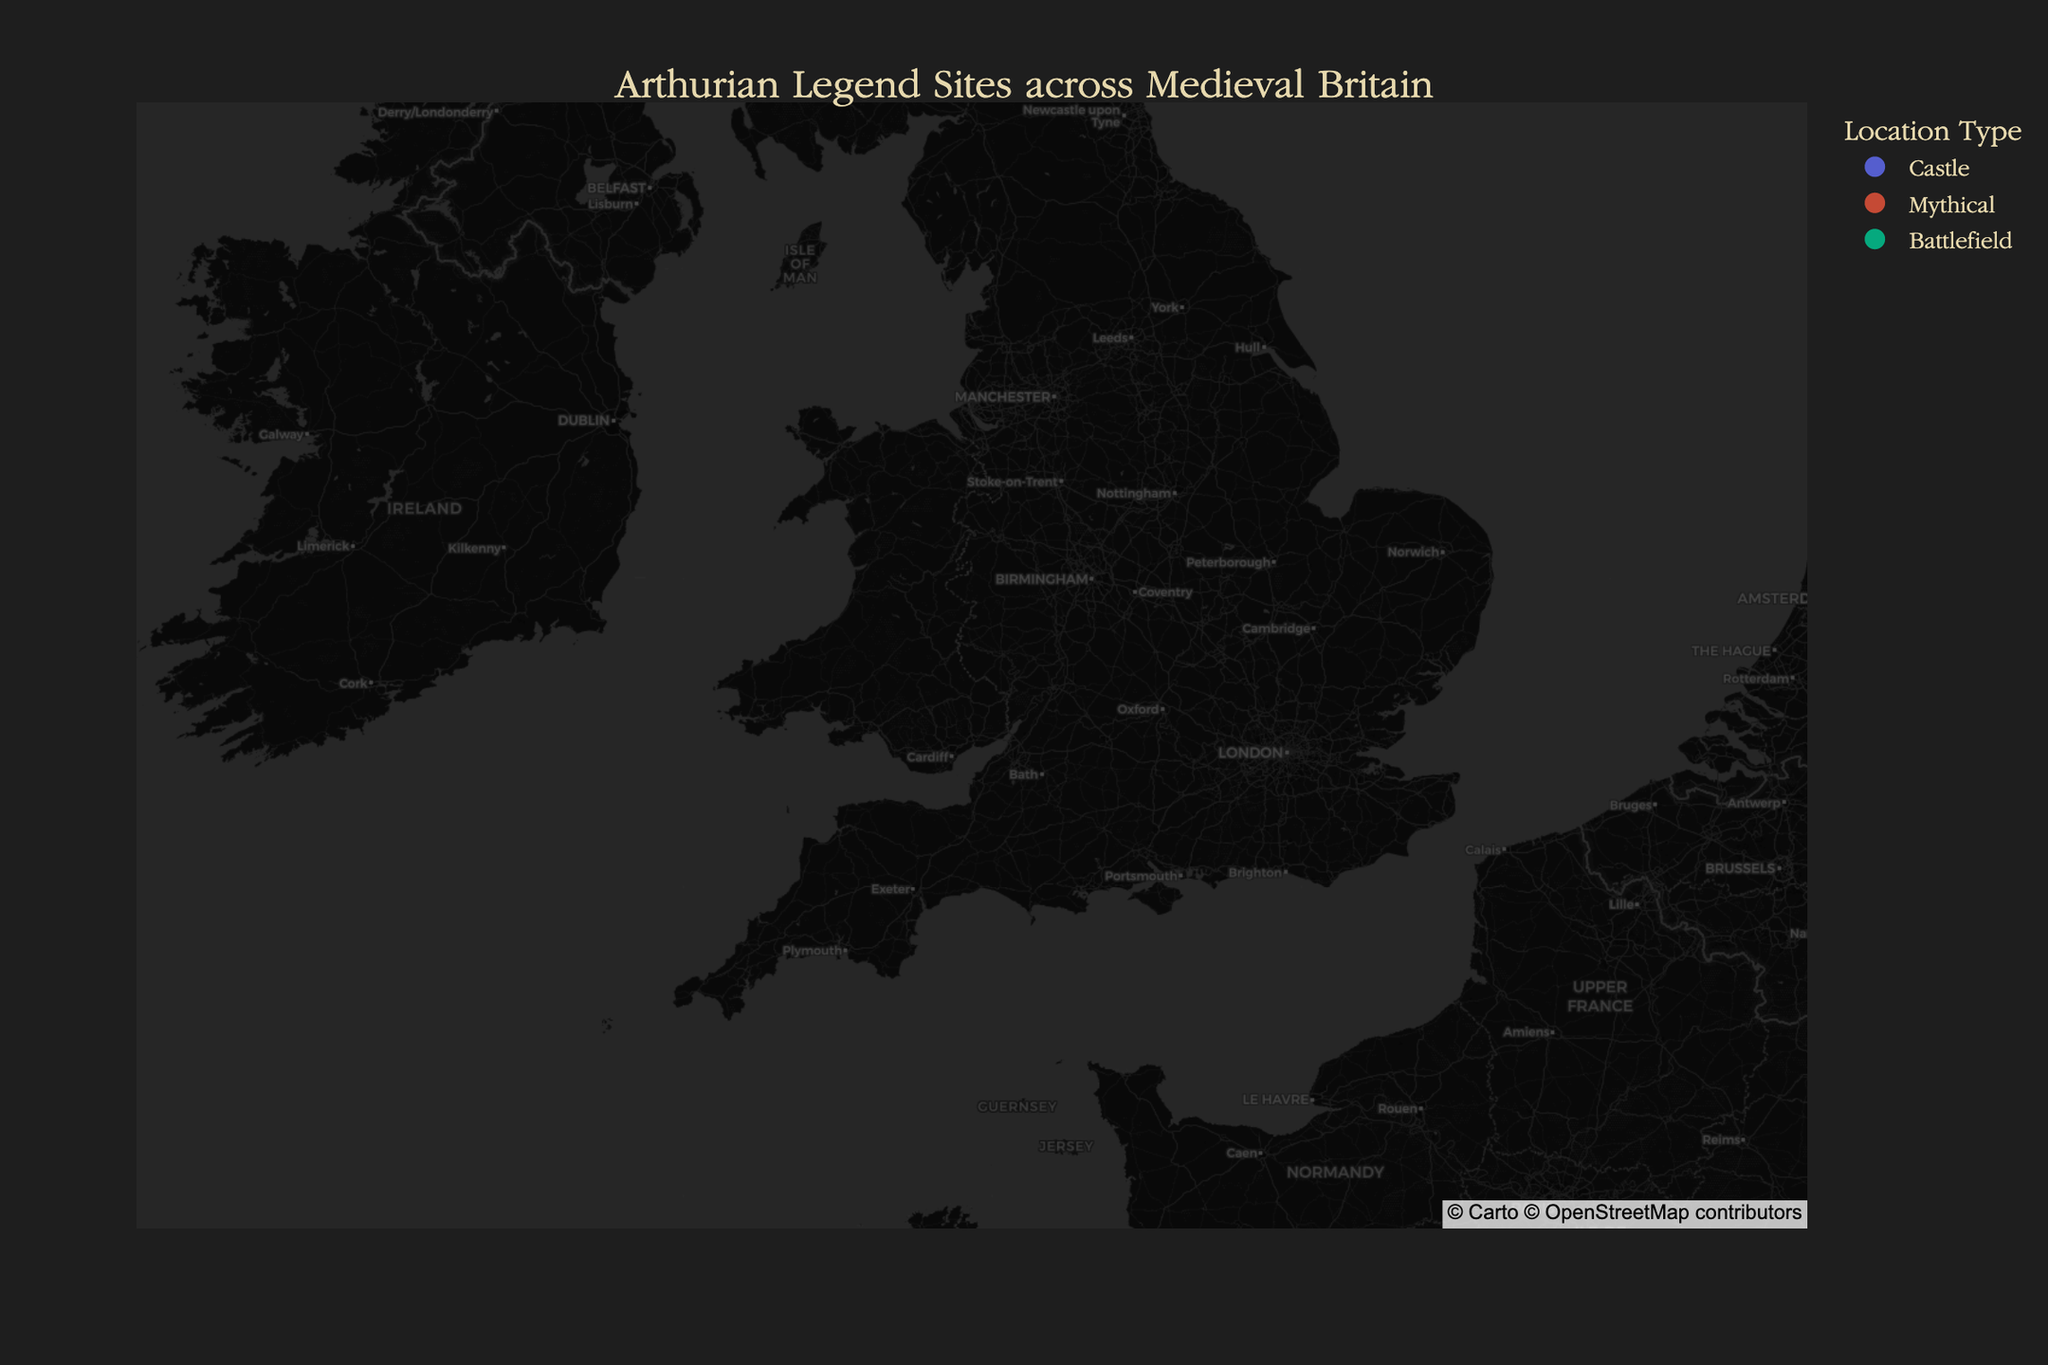What's the title of the figure? The title is usually positioned at the top center of the figure. By observing the figure, you can read the title directly.
Answer: Arthurian Legend Sites across Medieval Britain Which location is represented as the legendary birthplace of King Arthur? By hovering over the points or reading the descriptions of the locations in the legend, you can identify the specific site.
Answer: Tintagel Castle How many battlefields associated with the Arthurian legends are depicted on the map? By counting the locations under the "Battlefield" type in the legend or figure, you can determine the total number.
Answer: 2 Which castle is located furthest north on the map? By comparing the latitudinal coordinates of all castles and identifying the highest latitude value, you can find the northernmost castle.
Answer: Carlisle Castle Which mythical site is closest to the center of the map? Comparing the latitudinal and longitudinal coordinates of the mythical sites to the center of the map (lat: 52, lon: -3) will identify the closest one.
Answer: Dozmary Pool How many Arthurian legend sites are there in total? By counting all the points on the map or summing the total number of different types of locations in the legend, you can find the total number.
Answer: 12 Which castle is associated with Merlin and the red and white dragons? By referring to the descriptions provided for each location, you can identify the castle linked to Merlin and the dragons.
Answer: Dinas Emrys Are there more castles or mythical locations represented on the map? By counting the number of castles and mythical locations via the legend or plot, you can determine which type is more numerous.
Answer: More castles Which possible site of Arthur’s court is located further east – South Cadbury (Camelot) or Caerleon? By comparing the longitudinal coordinates (more negative values indicate more western) of South Cadbury and Caerleon, you can determine which is further east.
Answer: Caerleon What’s the average latitude of all mythical locations on the map? First, sum up the latitudes of all mythical locations: Glastonbury Tor (51.1445), Brocéliande Forest (48.0581), Dozmary Pool (50.5463), and Loch Arthur (54.9491). Then, divide by the number of sites.
Answer: (51.1445 + 48.0581 + 50.5463 + 54.9491) / 4 = 51.1745 